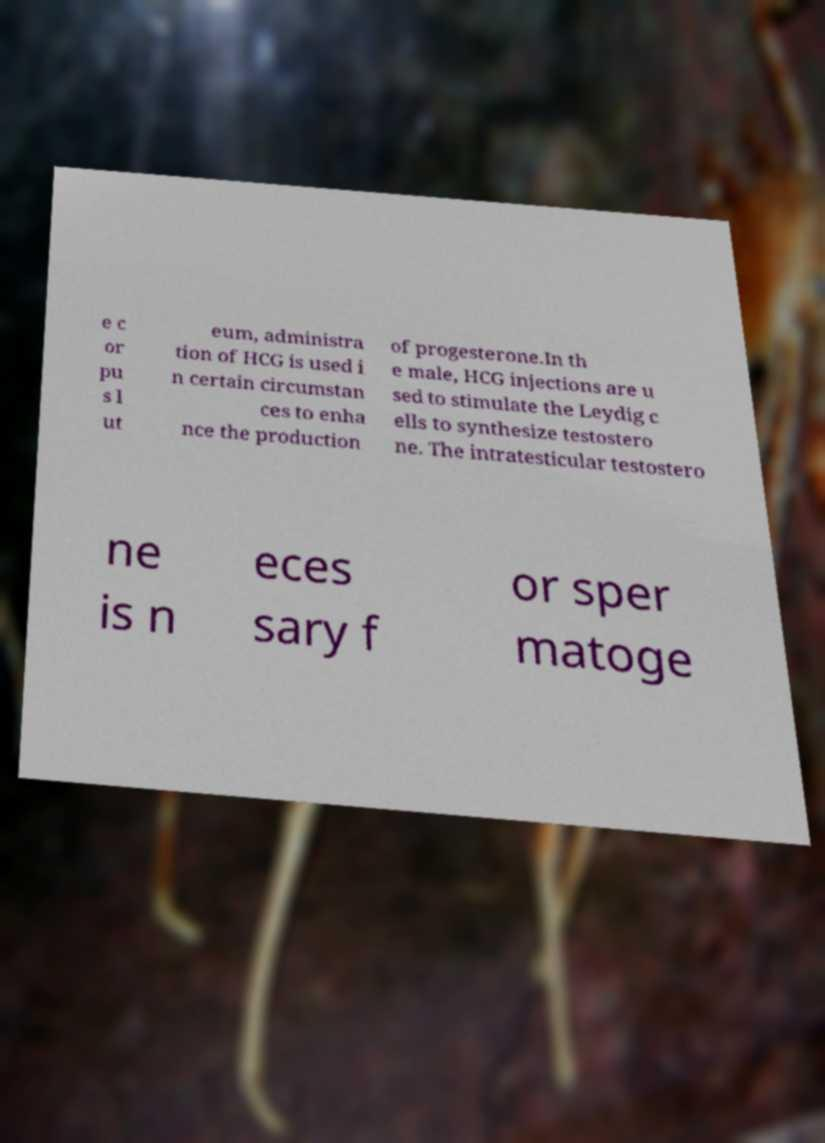For documentation purposes, I need the text within this image transcribed. Could you provide that? e c or pu s l ut eum, administra tion of HCG is used i n certain circumstan ces to enha nce the production of progesterone.In th e male, HCG injections are u sed to stimulate the Leydig c ells to synthesize testostero ne. The intratesticular testostero ne is n eces sary f or sper matoge 